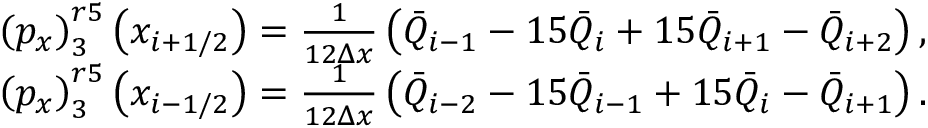Convert formula to latex. <formula><loc_0><loc_0><loc_500><loc_500>\begin{array} { r l } & { \left ( { { p } _ { x } } \right ) _ { 3 } ^ { r 5 } \left ( { { x } _ { i + 1 / 2 } } \right ) = \frac { 1 } { 1 2 \Delta x } \left ( { { { \bar { Q } } } _ { i - 1 } } - 1 5 { { { \bar { Q } } } _ { i } } + 1 5 { { { \bar { Q } } } _ { i + 1 } } - { { { \bar { Q } } } _ { i + 2 } } \right ) , } \\ & { \left ( { { p } _ { x } } \right ) _ { 3 } ^ { r 5 } \left ( { { x } _ { i - 1 / 2 } } \right ) = \frac { 1 } { 1 2 \Delta x } \left ( { { { \bar { Q } } } _ { i - 2 } } - 1 5 { { { \bar { Q } } } _ { i - 1 } } + 1 5 { { { \bar { Q } } } _ { i } } - { { { \bar { Q } } } _ { i + 1 } } \right ) . } \end{array}</formula> 